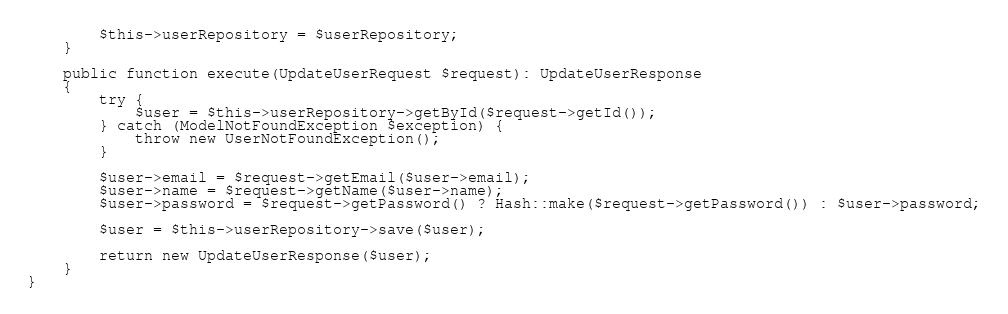<code> <loc_0><loc_0><loc_500><loc_500><_PHP_>        $this->userRepository = $userRepository;
    }

    public function execute(UpdateUserRequest $request): UpdateUserResponse
    {
        try {
            $user = $this->userRepository->getById($request->getId());
        } catch (ModelNotFoundException $exception) {
            throw new UserNotFoundException();
        }

        $user->email = $request->getEmail($user->email);
        $user->name = $request->getName($user->name);
        $user->password = $request->getPassword() ? Hash::make($request->getPassword()) : $user->password;

        $user = $this->userRepository->save($user);

        return new UpdateUserResponse($user);
    }
}</code> 